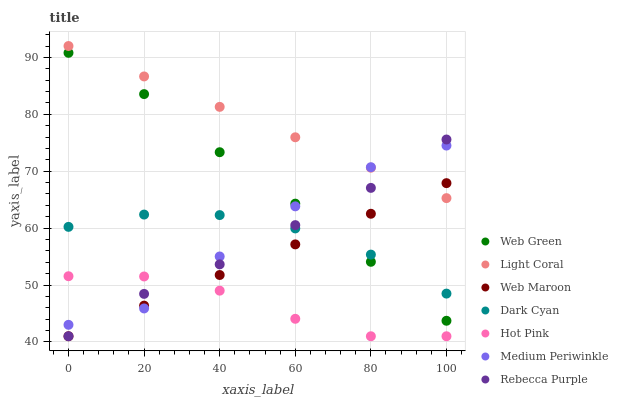Does Hot Pink have the minimum area under the curve?
Answer yes or no. Yes. Does Light Coral have the maximum area under the curve?
Answer yes or no. Yes. Does Web Maroon have the minimum area under the curve?
Answer yes or no. No. Does Web Maroon have the maximum area under the curve?
Answer yes or no. No. Is Web Maroon the smoothest?
Answer yes or no. Yes. Is Medium Periwinkle the roughest?
Answer yes or no. Yes. Is Hot Pink the smoothest?
Answer yes or no. No. Is Hot Pink the roughest?
Answer yes or no. No. Does Hot Pink have the lowest value?
Answer yes or no. Yes. Does Web Green have the lowest value?
Answer yes or no. No. Does Light Coral have the highest value?
Answer yes or no. Yes. Does Web Maroon have the highest value?
Answer yes or no. No. Is Hot Pink less than Dark Cyan?
Answer yes or no. Yes. Is Light Coral greater than Dark Cyan?
Answer yes or no. Yes. Does Medium Periwinkle intersect Rebecca Purple?
Answer yes or no. Yes. Is Medium Periwinkle less than Rebecca Purple?
Answer yes or no. No. Is Medium Periwinkle greater than Rebecca Purple?
Answer yes or no. No. Does Hot Pink intersect Dark Cyan?
Answer yes or no. No. 